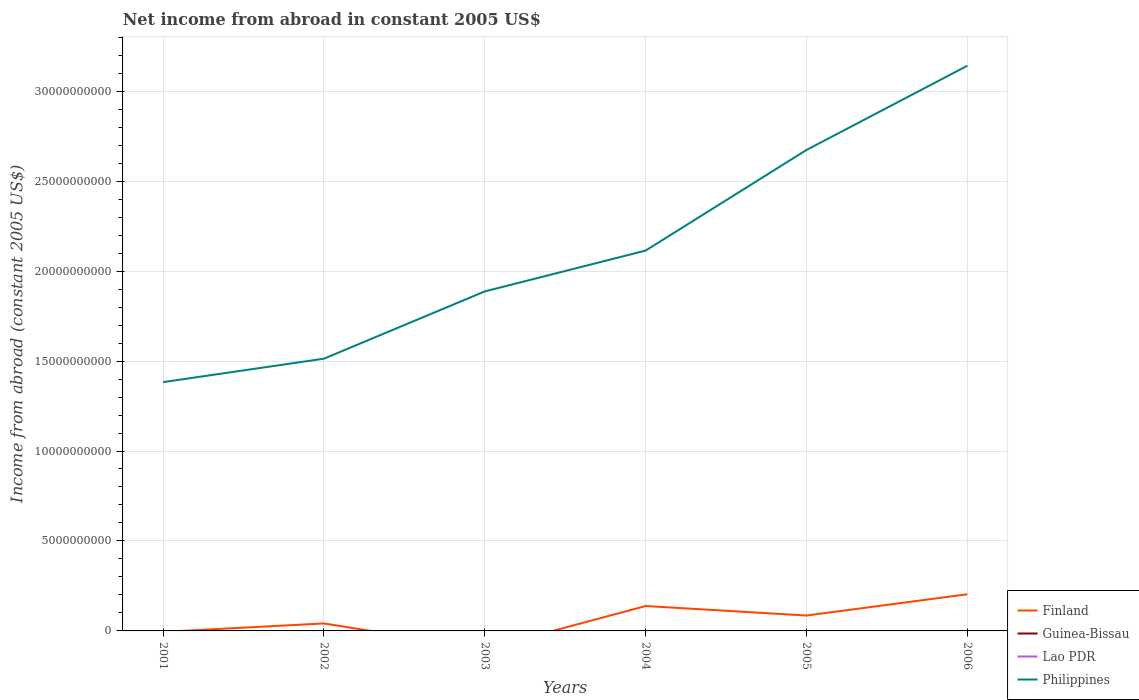Is the number of lines equal to the number of legend labels?
Your response must be concise. No. Across all years, what is the maximum net income from abroad in Philippines?
Offer a terse response. 1.38e+1. What is the total net income from abroad in Philippines in the graph?
Provide a succinct answer. -4.68e+09. What is the difference between the highest and the second highest net income from abroad in Philippines?
Provide a short and direct response. 1.76e+1. Is the net income from abroad in Lao PDR strictly greater than the net income from abroad in Philippines over the years?
Offer a very short reply. Yes. How many lines are there?
Offer a very short reply. 2. How many years are there in the graph?
Make the answer very short. 6. What is the difference between two consecutive major ticks on the Y-axis?
Provide a short and direct response. 5.00e+09. Are the values on the major ticks of Y-axis written in scientific E-notation?
Keep it short and to the point. No. Does the graph contain any zero values?
Offer a very short reply. Yes. How are the legend labels stacked?
Offer a terse response. Vertical. What is the title of the graph?
Your answer should be very brief. Net income from abroad in constant 2005 US$. What is the label or title of the Y-axis?
Your answer should be very brief. Income from abroad (constant 2005 US$). What is the Income from abroad (constant 2005 US$) of Finland in 2001?
Ensure brevity in your answer.  0. What is the Income from abroad (constant 2005 US$) in Lao PDR in 2001?
Give a very brief answer. 0. What is the Income from abroad (constant 2005 US$) of Philippines in 2001?
Your response must be concise. 1.38e+1. What is the Income from abroad (constant 2005 US$) in Finland in 2002?
Give a very brief answer. 4.16e+08. What is the Income from abroad (constant 2005 US$) of Guinea-Bissau in 2002?
Provide a succinct answer. 0. What is the Income from abroad (constant 2005 US$) in Philippines in 2002?
Give a very brief answer. 1.51e+1. What is the Income from abroad (constant 2005 US$) of Guinea-Bissau in 2003?
Offer a very short reply. 0. What is the Income from abroad (constant 2005 US$) of Lao PDR in 2003?
Make the answer very short. 0. What is the Income from abroad (constant 2005 US$) of Philippines in 2003?
Give a very brief answer. 1.89e+1. What is the Income from abroad (constant 2005 US$) in Finland in 2004?
Your response must be concise. 1.38e+09. What is the Income from abroad (constant 2005 US$) in Guinea-Bissau in 2004?
Offer a very short reply. 0. What is the Income from abroad (constant 2005 US$) in Lao PDR in 2004?
Make the answer very short. 0. What is the Income from abroad (constant 2005 US$) in Philippines in 2004?
Your answer should be very brief. 2.11e+1. What is the Income from abroad (constant 2005 US$) of Finland in 2005?
Your answer should be very brief. 8.56e+08. What is the Income from abroad (constant 2005 US$) in Philippines in 2005?
Give a very brief answer. 2.67e+1. What is the Income from abroad (constant 2005 US$) of Finland in 2006?
Your answer should be very brief. 2.04e+09. What is the Income from abroad (constant 2005 US$) in Guinea-Bissau in 2006?
Give a very brief answer. 0. What is the Income from abroad (constant 2005 US$) of Lao PDR in 2006?
Ensure brevity in your answer.  0. What is the Income from abroad (constant 2005 US$) in Philippines in 2006?
Offer a terse response. 3.14e+1. Across all years, what is the maximum Income from abroad (constant 2005 US$) of Finland?
Your answer should be very brief. 2.04e+09. Across all years, what is the maximum Income from abroad (constant 2005 US$) in Philippines?
Your answer should be compact. 3.14e+1. Across all years, what is the minimum Income from abroad (constant 2005 US$) in Philippines?
Provide a short and direct response. 1.38e+1. What is the total Income from abroad (constant 2005 US$) of Finland in the graph?
Offer a terse response. 4.69e+09. What is the total Income from abroad (constant 2005 US$) in Guinea-Bissau in the graph?
Offer a very short reply. 0. What is the total Income from abroad (constant 2005 US$) of Lao PDR in the graph?
Your answer should be very brief. 0. What is the total Income from abroad (constant 2005 US$) of Philippines in the graph?
Ensure brevity in your answer.  1.27e+11. What is the difference between the Income from abroad (constant 2005 US$) of Philippines in 2001 and that in 2002?
Your answer should be very brief. -1.30e+09. What is the difference between the Income from abroad (constant 2005 US$) in Philippines in 2001 and that in 2003?
Ensure brevity in your answer.  -5.04e+09. What is the difference between the Income from abroad (constant 2005 US$) of Philippines in 2001 and that in 2004?
Provide a succinct answer. -7.31e+09. What is the difference between the Income from abroad (constant 2005 US$) of Philippines in 2001 and that in 2005?
Make the answer very short. -1.29e+1. What is the difference between the Income from abroad (constant 2005 US$) of Philippines in 2001 and that in 2006?
Your answer should be compact. -1.76e+1. What is the difference between the Income from abroad (constant 2005 US$) in Philippines in 2002 and that in 2003?
Offer a terse response. -3.74e+09. What is the difference between the Income from abroad (constant 2005 US$) of Finland in 2002 and that in 2004?
Provide a succinct answer. -9.68e+08. What is the difference between the Income from abroad (constant 2005 US$) in Philippines in 2002 and that in 2004?
Offer a very short reply. -6.01e+09. What is the difference between the Income from abroad (constant 2005 US$) in Finland in 2002 and that in 2005?
Give a very brief answer. -4.40e+08. What is the difference between the Income from abroad (constant 2005 US$) of Philippines in 2002 and that in 2005?
Your answer should be very brief. -1.16e+1. What is the difference between the Income from abroad (constant 2005 US$) in Finland in 2002 and that in 2006?
Ensure brevity in your answer.  -1.62e+09. What is the difference between the Income from abroad (constant 2005 US$) of Philippines in 2002 and that in 2006?
Make the answer very short. -1.63e+1. What is the difference between the Income from abroad (constant 2005 US$) in Philippines in 2003 and that in 2004?
Your answer should be very brief. -2.27e+09. What is the difference between the Income from abroad (constant 2005 US$) of Philippines in 2003 and that in 2005?
Your answer should be compact. -7.86e+09. What is the difference between the Income from abroad (constant 2005 US$) of Philippines in 2003 and that in 2006?
Your answer should be compact. -1.25e+1. What is the difference between the Income from abroad (constant 2005 US$) in Finland in 2004 and that in 2005?
Your answer should be very brief. 5.29e+08. What is the difference between the Income from abroad (constant 2005 US$) in Philippines in 2004 and that in 2005?
Your answer should be compact. -5.59e+09. What is the difference between the Income from abroad (constant 2005 US$) of Finland in 2004 and that in 2006?
Provide a succinct answer. -6.53e+08. What is the difference between the Income from abroad (constant 2005 US$) in Philippines in 2004 and that in 2006?
Give a very brief answer. -1.03e+1. What is the difference between the Income from abroad (constant 2005 US$) in Finland in 2005 and that in 2006?
Provide a succinct answer. -1.18e+09. What is the difference between the Income from abroad (constant 2005 US$) of Philippines in 2005 and that in 2006?
Keep it short and to the point. -4.68e+09. What is the difference between the Income from abroad (constant 2005 US$) of Finland in 2002 and the Income from abroad (constant 2005 US$) of Philippines in 2003?
Offer a terse response. -1.85e+1. What is the difference between the Income from abroad (constant 2005 US$) of Finland in 2002 and the Income from abroad (constant 2005 US$) of Philippines in 2004?
Make the answer very short. -2.07e+1. What is the difference between the Income from abroad (constant 2005 US$) of Finland in 2002 and the Income from abroad (constant 2005 US$) of Philippines in 2005?
Your response must be concise. -2.63e+1. What is the difference between the Income from abroad (constant 2005 US$) of Finland in 2002 and the Income from abroad (constant 2005 US$) of Philippines in 2006?
Provide a short and direct response. -3.10e+1. What is the difference between the Income from abroad (constant 2005 US$) of Finland in 2004 and the Income from abroad (constant 2005 US$) of Philippines in 2005?
Offer a very short reply. -2.53e+1. What is the difference between the Income from abroad (constant 2005 US$) of Finland in 2004 and the Income from abroad (constant 2005 US$) of Philippines in 2006?
Offer a terse response. -3.00e+1. What is the difference between the Income from abroad (constant 2005 US$) of Finland in 2005 and the Income from abroad (constant 2005 US$) of Philippines in 2006?
Provide a succinct answer. -3.06e+1. What is the average Income from abroad (constant 2005 US$) in Finland per year?
Provide a succinct answer. 7.82e+08. What is the average Income from abroad (constant 2005 US$) in Philippines per year?
Your answer should be compact. 2.12e+1. In the year 2002, what is the difference between the Income from abroad (constant 2005 US$) of Finland and Income from abroad (constant 2005 US$) of Philippines?
Your response must be concise. -1.47e+1. In the year 2004, what is the difference between the Income from abroad (constant 2005 US$) of Finland and Income from abroad (constant 2005 US$) of Philippines?
Keep it short and to the point. -1.98e+1. In the year 2005, what is the difference between the Income from abroad (constant 2005 US$) of Finland and Income from abroad (constant 2005 US$) of Philippines?
Make the answer very short. -2.59e+1. In the year 2006, what is the difference between the Income from abroad (constant 2005 US$) of Finland and Income from abroad (constant 2005 US$) of Philippines?
Offer a terse response. -2.94e+1. What is the ratio of the Income from abroad (constant 2005 US$) in Philippines in 2001 to that in 2002?
Offer a very short reply. 0.91. What is the ratio of the Income from abroad (constant 2005 US$) in Philippines in 2001 to that in 2003?
Ensure brevity in your answer.  0.73. What is the ratio of the Income from abroad (constant 2005 US$) in Philippines in 2001 to that in 2004?
Your answer should be very brief. 0.65. What is the ratio of the Income from abroad (constant 2005 US$) of Philippines in 2001 to that in 2005?
Keep it short and to the point. 0.52. What is the ratio of the Income from abroad (constant 2005 US$) of Philippines in 2001 to that in 2006?
Provide a succinct answer. 0.44. What is the ratio of the Income from abroad (constant 2005 US$) in Philippines in 2002 to that in 2003?
Keep it short and to the point. 0.8. What is the ratio of the Income from abroad (constant 2005 US$) of Finland in 2002 to that in 2004?
Provide a short and direct response. 0.3. What is the ratio of the Income from abroad (constant 2005 US$) in Philippines in 2002 to that in 2004?
Ensure brevity in your answer.  0.72. What is the ratio of the Income from abroad (constant 2005 US$) in Finland in 2002 to that in 2005?
Your answer should be compact. 0.49. What is the ratio of the Income from abroad (constant 2005 US$) of Philippines in 2002 to that in 2005?
Ensure brevity in your answer.  0.57. What is the ratio of the Income from abroad (constant 2005 US$) in Finland in 2002 to that in 2006?
Your answer should be compact. 0.2. What is the ratio of the Income from abroad (constant 2005 US$) in Philippines in 2002 to that in 2006?
Your response must be concise. 0.48. What is the ratio of the Income from abroad (constant 2005 US$) in Philippines in 2003 to that in 2004?
Offer a terse response. 0.89. What is the ratio of the Income from abroad (constant 2005 US$) in Philippines in 2003 to that in 2005?
Offer a terse response. 0.71. What is the ratio of the Income from abroad (constant 2005 US$) of Philippines in 2003 to that in 2006?
Make the answer very short. 0.6. What is the ratio of the Income from abroad (constant 2005 US$) of Finland in 2004 to that in 2005?
Keep it short and to the point. 1.62. What is the ratio of the Income from abroad (constant 2005 US$) of Philippines in 2004 to that in 2005?
Provide a short and direct response. 0.79. What is the ratio of the Income from abroad (constant 2005 US$) in Finland in 2004 to that in 2006?
Provide a short and direct response. 0.68. What is the ratio of the Income from abroad (constant 2005 US$) in Philippines in 2004 to that in 2006?
Provide a succinct answer. 0.67. What is the ratio of the Income from abroad (constant 2005 US$) in Finland in 2005 to that in 2006?
Offer a very short reply. 0.42. What is the ratio of the Income from abroad (constant 2005 US$) in Philippines in 2005 to that in 2006?
Offer a terse response. 0.85. What is the difference between the highest and the second highest Income from abroad (constant 2005 US$) in Finland?
Ensure brevity in your answer.  6.53e+08. What is the difference between the highest and the second highest Income from abroad (constant 2005 US$) in Philippines?
Provide a short and direct response. 4.68e+09. What is the difference between the highest and the lowest Income from abroad (constant 2005 US$) of Finland?
Give a very brief answer. 2.04e+09. What is the difference between the highest and the lowest Income from abroad (constant 2005 US$) of Philippines?
Ensure brevity in your answer.  1.76e+1. 